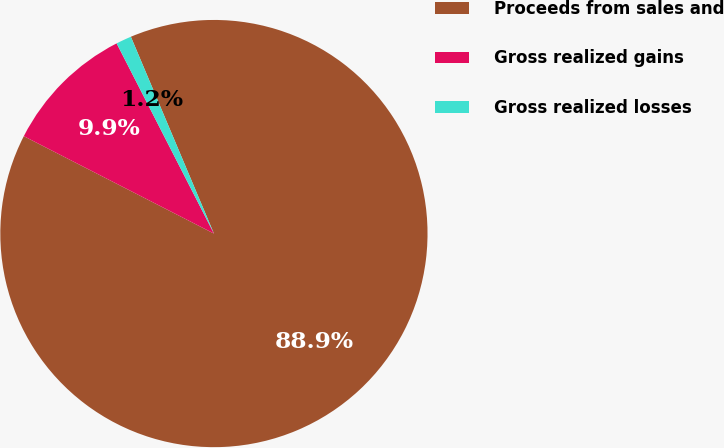<chart> <loc_0><loc_0><loc_500><loc_500><pie_chart><fcel>Proceeds from sales and<fcel>Gross realized gains<fcel>Gross realized losses<nl><fcel>88.89%<fcel>9.94%<fcel>1.17%<nl></chart> 